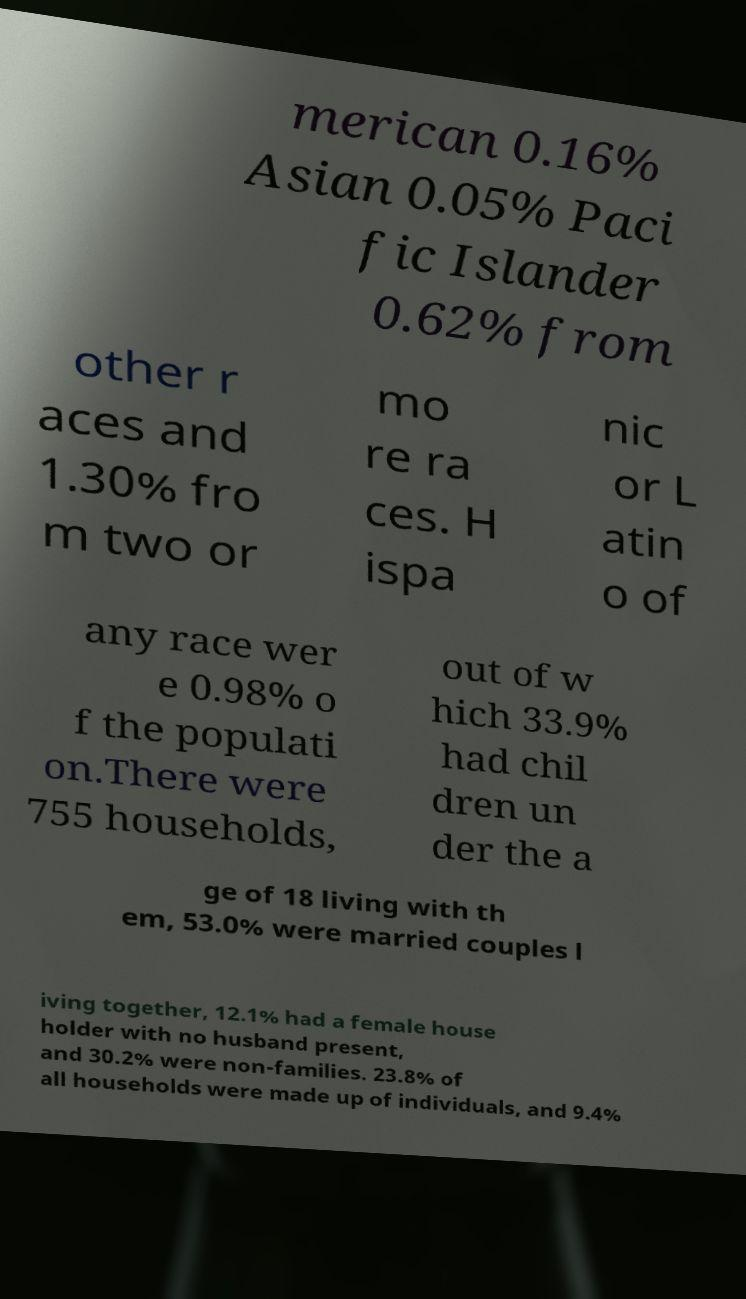Could you assist in decoding the text presented in this image and type it out clearly? merican 0.16% Asian 0.05% Paci fic Islander 0.62% from other r aces and 1.30% fro m two or mo re ra ces. H ispa nic or L atin o of any race wer e 0.98% o f the populati on.There were 755 households, out of w hich 33.9% had chil dren un der the a ge of 18 living with th em, 53.0% were married couples l iving together, 12.1% had a female house holder with no husband present, and 30.2% were non-families. 23.8% of all households were made up of individuals, and 9.4% 